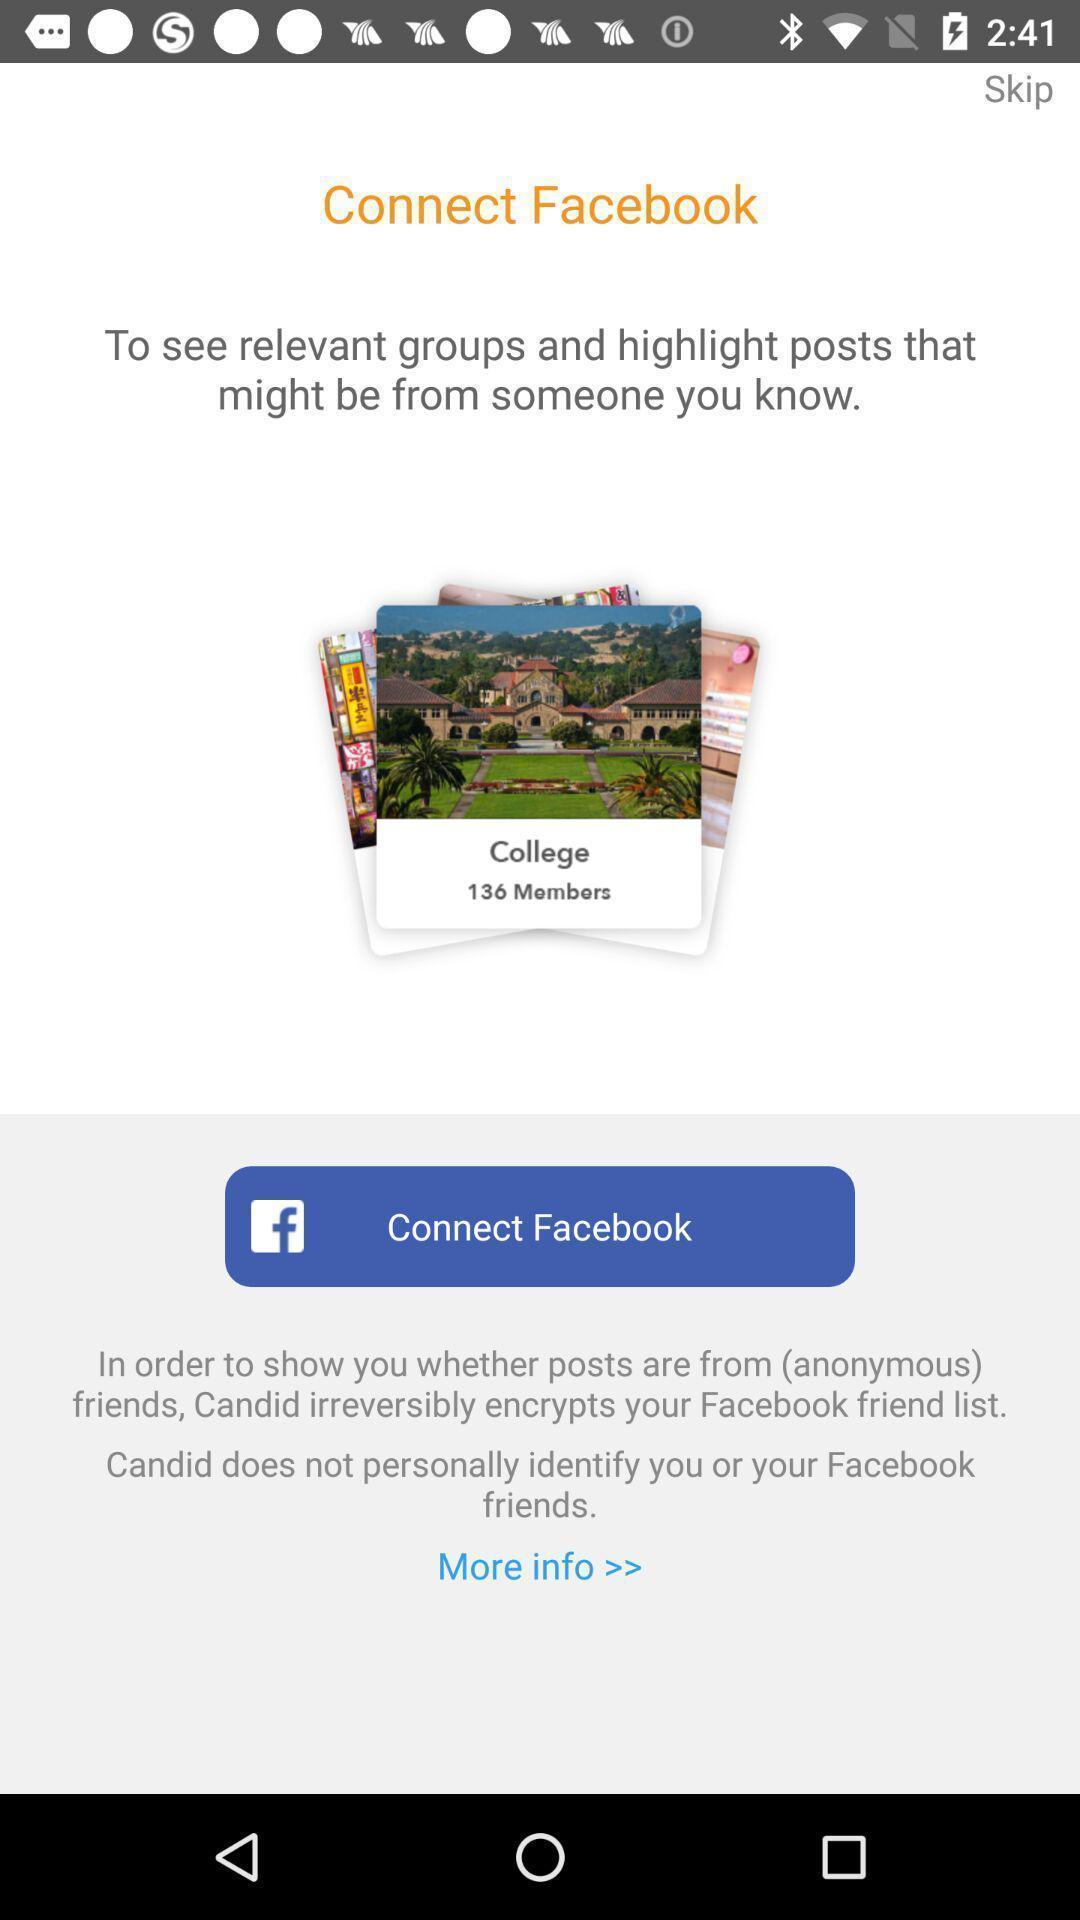What details can you identify in this image? Welcome page for display app. 